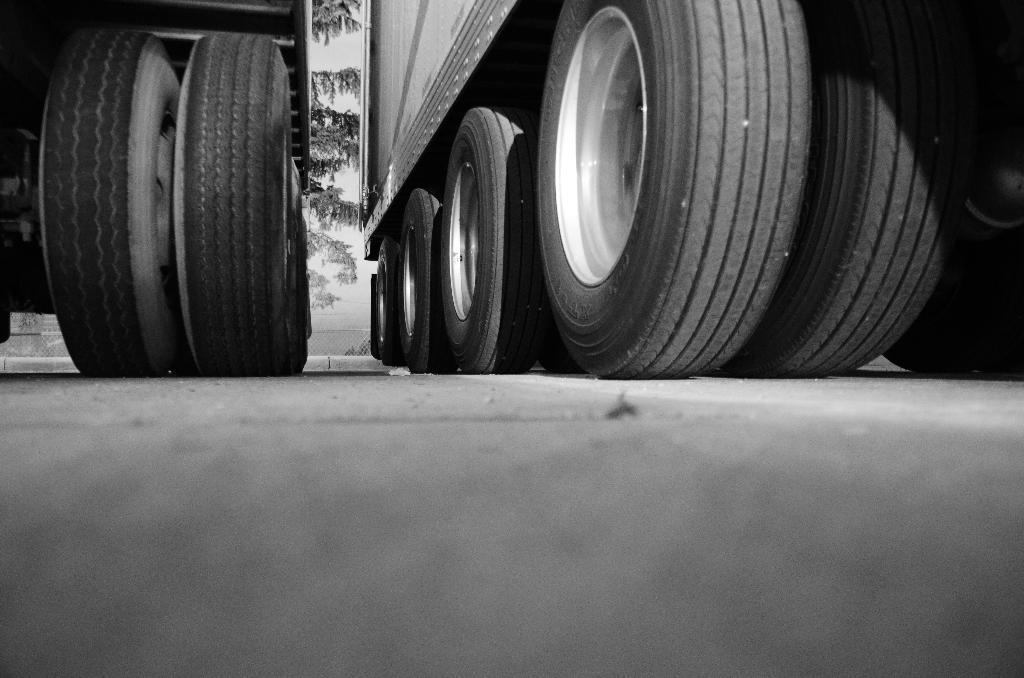How would you summarize this image in a sentence or two? There are tyres of 2 vehicles. Behind them there are trees. 